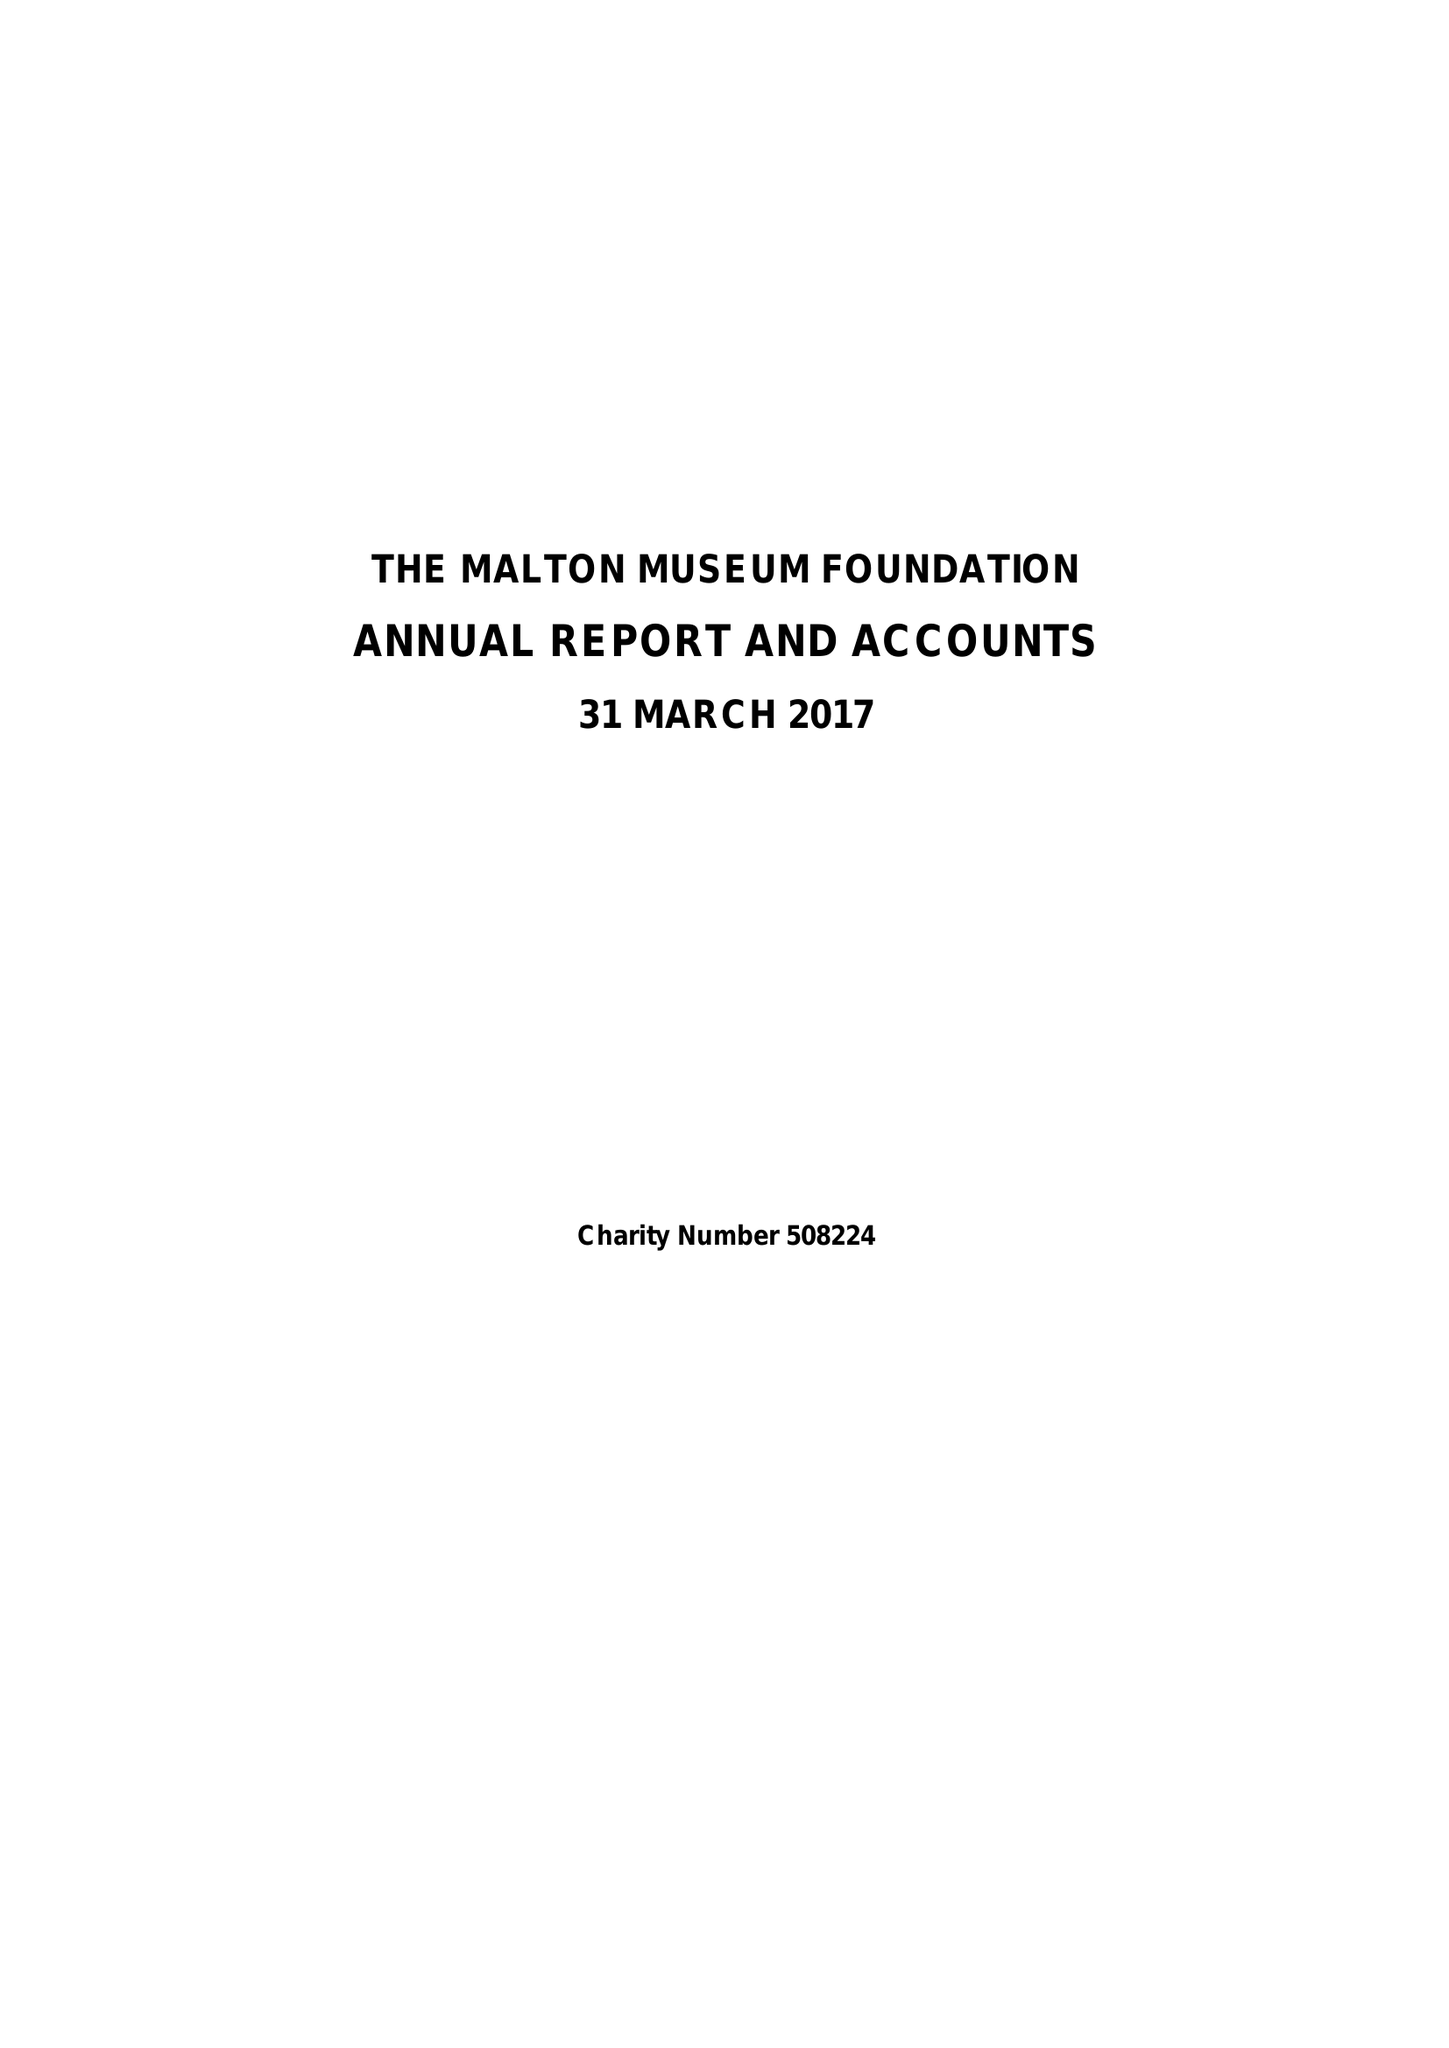What is the value for the address__postcode?
Answer the question using a single word or phrase. YO17 6UN 